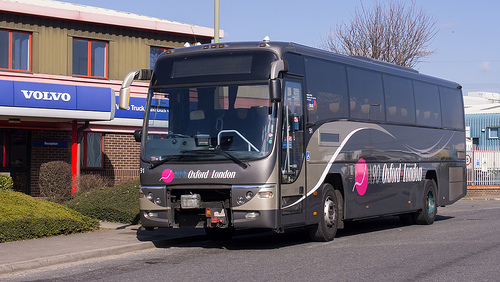Please provide a short description for this region: [0.76, 0.36, 0.85, 0.47]. Another window of the same big bus, offering a glimpse into the vehicle's interior that includes partial views of passenger seating and curtains. 